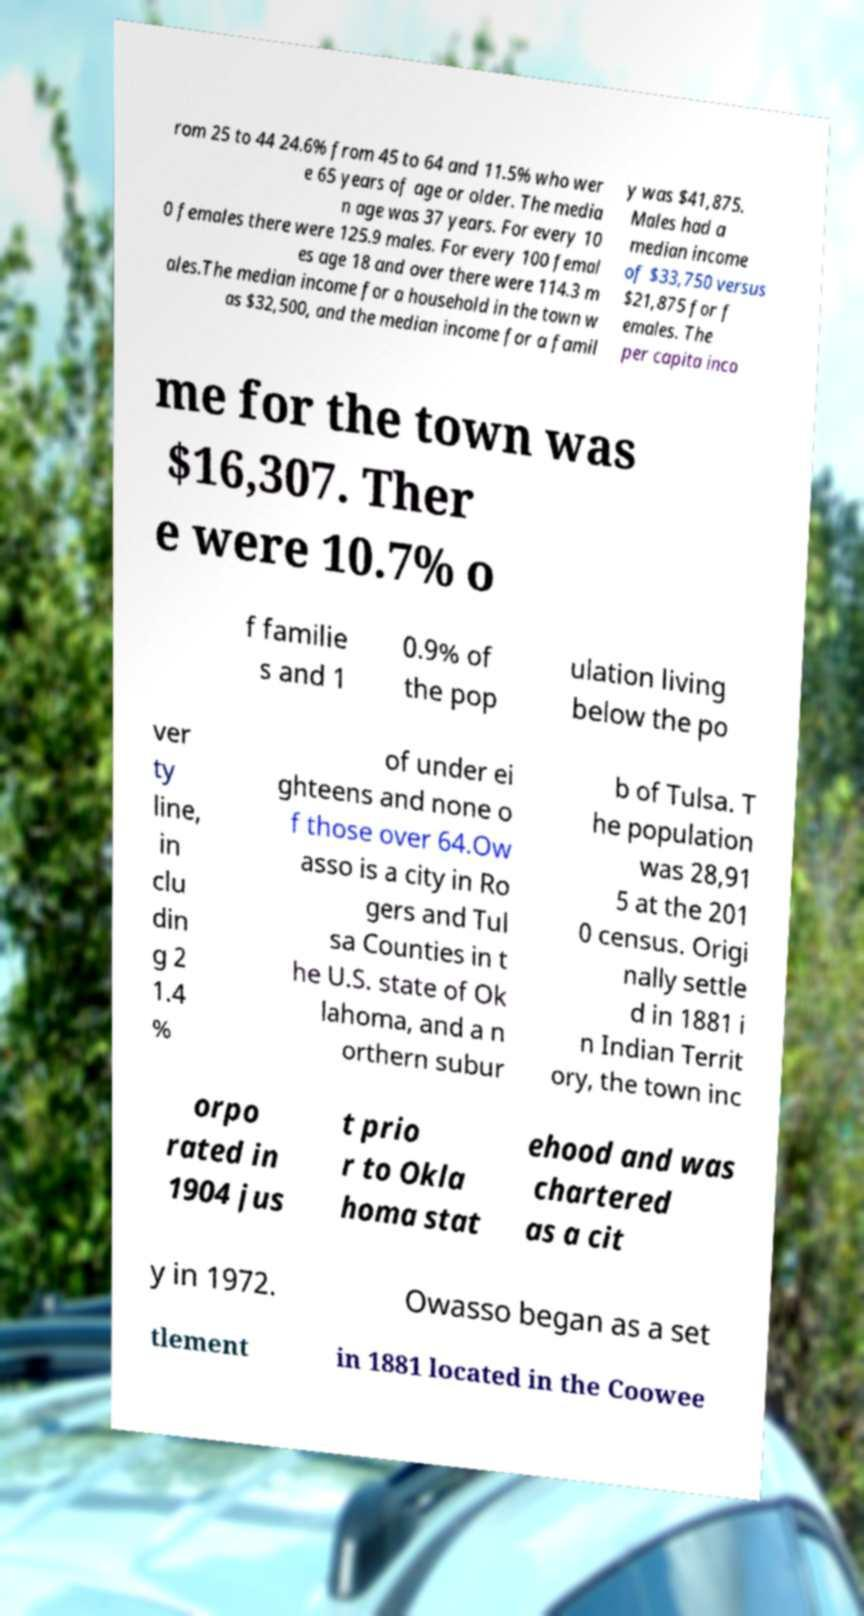What messages or text are displayed in this image? I need them in a readable, typed format. rom 25 to 44 24.6% from 45 to 64 and 11.5% who wer e 65 years of age or older. The media n age was 37 years. For every 10 0 females there were 125.9 males. For every 100 femal es age 18 and over there were 114.3 m ales.The median income for a household in the town w as $32,500, and the median income for a famil y was $41,875. Males had a median income of $33,750 versus $21,875 for f emales. The per capita inco me for the town was $16,307. Ther e were 10.7% o f familie s and 1 0.9% of the pop ulation living below the po ver ty line, in clu din g 2 1.4 % of under ei ghteens and none o f those over 64.Ow asso is a city in Ro gers and Tul sa Counties in t he U.S. state of Ok lahoma, and a n orthern subur b of Tulsa. T he population was 28,91 5 at the 201 0 census. Origi nally settle d in 1881 i n Indian Territ ory, the town inc orpo rated in 1904 jus t prio r to Okla homa stat ehood and was chartered as a cit y in 1972. Owasso began as a set tlement in 1881 located in the Coowee 